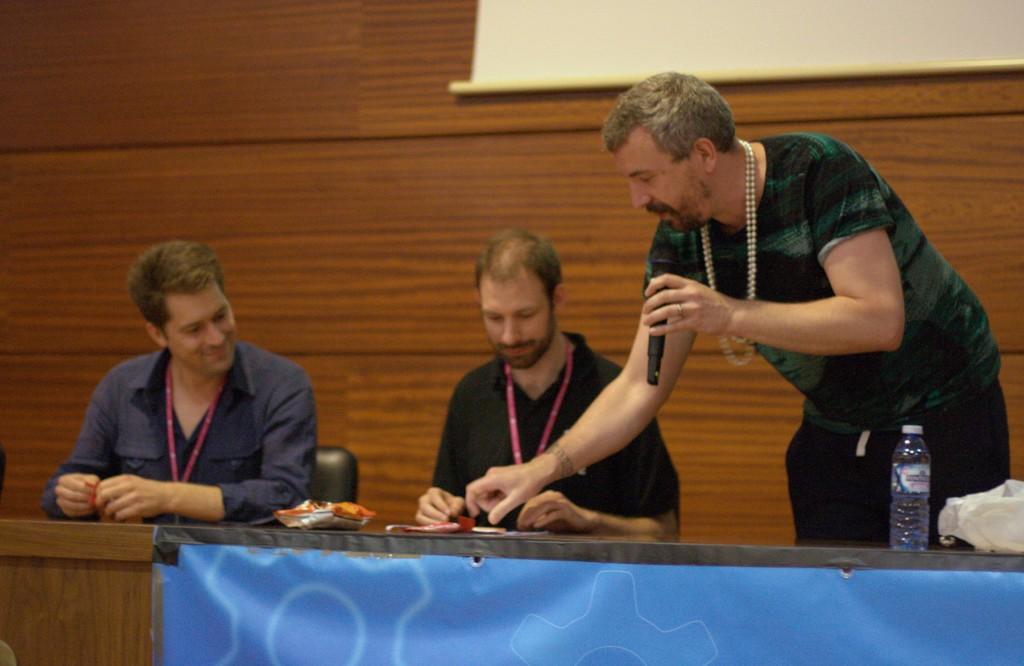In one or two sentences, can you explain what this image depicts? In this picture we can see a man wearing a pearl chain over his neck and he is holding a mike and explaining something to this man. This both men are sitting on the chairs in front of a table. Here we can see a packet and a water bottle on the table. On the background partial part of the projector screen is visible. 